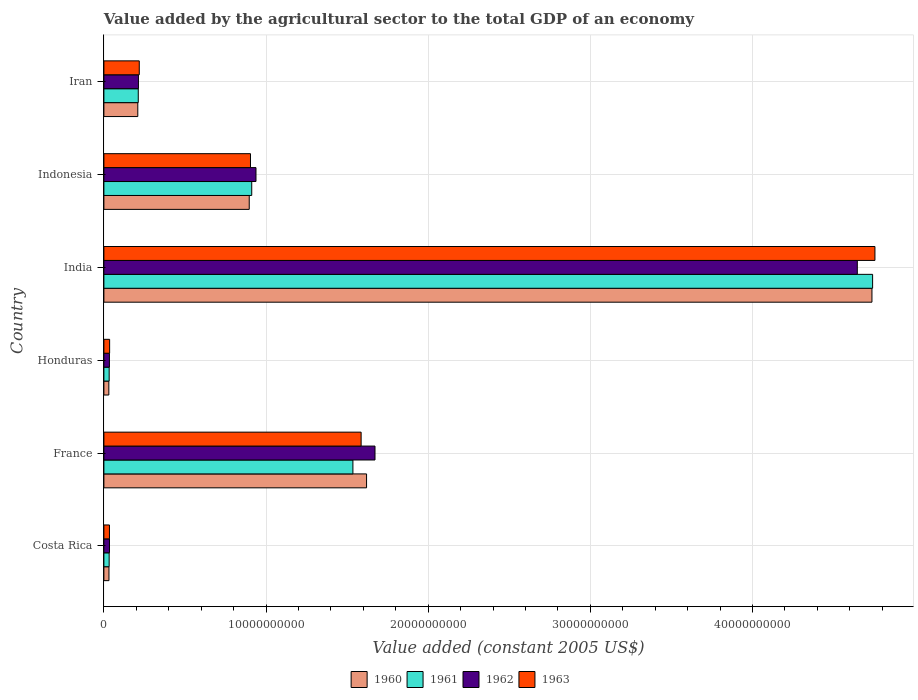How many groups of bars are there?
Keep it short and to the point. 6. Are the number of bars per tick equal to the number of legend labels?
Provide a succinct answer. Yes. What is the label of the 4th group of bars from the top?
Provide a short and direct response. Honduras. What is the value added by the agricultural sector in 1963 in Iran?
Offer a very short reply. 2.18e+09. Across all countries, what is the maximum value added by the agricultural sector in 1960?
Make the answer very short. 4.74e+1. Across all countries, what is the minimum value added by the agricultural sector in 1963?
Provide a succinct answer. 3.43e+08. What is the total value added by the agricultural sector in 1962 in the graph?
Offer a terse response. 7.54e+1. What is the difference between the value added by the agricultural sector in 1963 in Indonesia and that in Iran?
Provide a short and direct response. 6.86e+09. What is the difference between the value added by the agricultural sector in 1960 in Costa Rica and the value added by the agricultural sector in 1963 in Iran?
Make the answer very short. -1.87e+09. What is the average value added by the agricultural sector in 1961 per country?
Provide a short and direct response. 1.24e+1. What is the difference between the value added by the agricultural sector in 1963 and value added by the agricultural sector in 1961 in Costa Rica?
Your response must be concise. 1.89e+07. In how many countries, is the value added by the agricultural sector in 1963 greater than 16000000000 US$?
Make the answer very short. 1. What is the ratio of the value added by the agricultural sector in 1960 in France to that in Honduras?
Provide a succinct answer. 53.05. Is the value added by the agricultural sector in 1961 in France less than that in Indonesia?
Offer a very short reply. No. Is the difference between the value added by the agricultural sector in 1963 in Honduras and Iran greater than the difference between the value added by the agricultural sector in 1961 in Honduras and Iran?
Your answer should be very brief. No. What is the difference between the highest and the second highest value added by the agricultural sector in 1963?
Give a very brief answer. 3.17e+1. What is the difference between the highest and the lowest value added by the agricultural sector in 1963?
Make the answer very short. 4.72e+1. In how many countries, is the value added by the agricultural sector in 1962 greater than the average value added by the agricultural sector in 1962 taken over all countries?
Your answer should be compact. 2. Is it the case that in every country, the sum of the value added by the agricultural sector in 1961 and value added by the agricultural sector in 1960 is greater than the sum of value added by the agricultural sector in 1963 and value added by the agricultural sector in 1962?
Your answer should be very brief. No. Are the values on the major ticks of X-axis written in scientific E-notation?
Make the answer very short. No. Does the graph contain any zero values?
Your response must be concise. No. Does the graph contain grids?
Ensure brevity in your answer.  Yes. What is the title of the graph?
Keep it short and to the point. Value added by the agricultural sector to the total GDP of an economy. What is the label or title of the X-axis?
Offer a terse response. Value added (constant 2005 US$). What is the Value added (constant 2005 US$) of 1960 in Costa Rica?
Keep it short and to the point. 3.13e+08. What is the Value added (constant 2005 US$) of 1961 in Costa Rica?
Offer a very short reply. 3.24e+08. What is the Value added (constant 2005 US$) of 1962 in Costa Rica?
Offer a terse response. 3.44e+08. What is the Value added (constant 2005 US$) of 1963 in Costa Rica?
Provide a succinct answer. 3.43e+08. What is the Value added (constant 2005 US$) in 1960 in France?
Ensure brevity in your answer.  1.62e+1. What is the Value added (constant 2005 US$) in 1961 in France?
Offer a very short reply. 1.54e+1. What is the Value added (constant 2005 US$) of 1962 in France?
Your answer should be compact. 1.67e+1. What is the Value added (constant 2005 US$) in 1963 in France?
Provide a short and direct response. 1.59e+1. What is the Value added (constant 2005 US$) in 1960 in Honduras?
Your answer should be very brief. 3.05e+08. What is the Value added (constant 2005 US$) of 1961 in Honduras?
Your answer should be very brief. 3.25e+08. What is the Value added (constant 2005 US$) of 1962 in Honduras?
Offer a terse response. 3.41e+08. What is the Value added (constant 2005 US$) of 1963 in Honduras?
Provide a short and direct response. 3.53e+08. What is the Value added (constant 2005 US$) in 1960 in India?
Keep it short and to the point. 4.74e+1. What is the Value added (constant 2005 US$) in 1961 in India?
Offer a very short reply. 4.74e+1. What is the Value added (constant 2005 US$) of 1962 in India?
Keep it short and to the point. 4.65e+1. What is the Value added (constant 2005 US$) of 1963 in India?
Your response must be concise. 4.76e+1. What is the Value added (constant 2005 US$) of 1960 in Indonesia?
Your response must be concise. 8.96e+09. What is the Value added (constant 2005 US$) of 1961 in Indonesia?
Provide a short and direct response. 9.12e+09. What is the Value added (constant 2005 US$) in 1962 in Indonesia?
Give a very brief answer. 9.38e+09. What is the Value added (constant 2005 US$) of 1963 in Indonesia?
Make the answer very short. 9.04e+09. What is the Value added (constant 2005 US$) of 1960 in Iran?
Keep it short and to the point. 2.09e+09. What is the Value added (constant 2005 US$) of 1961 in Iran?
Provide a short and direct response. 2.12e+09. What is the Value added (constant 2005 US$) in 1962 in Iran?
Provide a short and direct response. 2.13e+09. What is the Value added (constant 2005 US$) in 1963 in Iran?
Offer a terse response. 2.18e+09. Across all countries, what is the maximum Value added (constant 2005 US$) in 1960?
Ensure brevity in your answer.  4.74e+1. Across all countries, what is the maximum Value added (constant 2005 US$) of 1961?
Ensure brevity in your answer.  4.74e+1. Across all countries, what is the maximum Value added (constant 2005 US$) of 1962?
Keep it short and to the point. 4.65e+1. Across all countries, what is the maximum Value added (constant 2005 US$) of 1963?
Offer a very short reply. 4.76e+1. Across all countries, what is the minimum Value added (constant 2005 US$) of 1960?
Ensure brevity in your answer.  3.05e+08. Across all countries, what is the minimum Value added (constant 2005 US$) of 1961?
Your response must be concise. 3.24e+08. Across all countries, what is the minimum Value added (constant 2005 US$) of 1962?
Provide a succinct answer. 3.41e+08. Across all countries, what is the minimum Value added (constant 2005 US$) in 1963?
Ensure brevity in your answer.  3.43e+08. What is the total Value added (constant 2005 US$) in 1960 in the graph?
Keep it short and to the point. 7.52e+1. What is the total Value added (constant 2005 US$) in 1961 in the graph?
Offer a very short reply. 7.47e+1. What is the total Value added (constant 2005 US$) of 1962 in the graph?
Give a very brief answer. 7.54e+1. What is the total Value added (constant 2005 US$) of 1963 in the graph?
Ensure brevity in your answer.  7.53e+1. What is the difference between the Value added (constant 2005 US$) of 1960 in Costa Rica and that in France?
Offer a terse response. -1.59e+1. What is the difference between the Value added (constant 2005 US$) of 1961 in Costa Rica and that in France?
Offer a very short reply. -1.50e+1. What is the difference between the Value added (constant 2005 US$) of 1962 in Costa Rica and that in France?
Your answer should be very brief. -1.64e+1. What is the difference between the Value added (constant 2005 US$) of 1963 in Costa Rica and that in France?
Provide a short and direct response. -1.55e+1. What is the difference between the Value added (constant 2005 US$) of 1960 in Costa Rica and that in Honduras?
Provide a succinct answer. 7.61e+06. What is the difference between the Value added (constant 2005 US$) of 1961 in Costa Rica and that in Honduras?
Offer a very short reply. -8.14e+05. What is the difference between the Value added (constant 2005 US$) in 1962 in Costa Rica and that in Honduras?
Offer a very short reply. 3.61e+06. What is the difference between the Value added (constant 2005 US$) of 1963 in Costa Rica and that in Honduras?
Your response must be concise. -9.78e+06. What is the difference between the Value added (constant 2005 US$) of 1960 in Costa Rica and that in India?
Give a very brief answer. -4.71e+1. What is the difference between the Value added (constant 2005 US$) in 1961 in Costa Rica and that in India?
Offer a very short reply. -4.71e+1. What is the difference between the Value added (constant 2005 US$) in 1962 in Costa Rica and that in India?
Ensure brevity in your answer.  -4.61e+1. What is the difference between the Value added (constant 2005 US$) of 1963 in Costa Rica and that in India?
Your answer should be compact. -4.72e+1. What is the difference between the Value added (constant 2005 US$) of 1960 in Costa Rica and that in Indonesia?
Your response must be concise. -8.65e+09. What is the difference between the Value added (constant 2005 US$) in 1961 in Costa Rica and that in Indonesia?
Ensure brevity in your answer.  -8.79e+09. What is the difference between the Value added (constant 2005 US$) of 1962 in Costa Rica and that in Indonesia?
Your answer should be compact. -9.03e+09. What is the difference between the Value added (constant 2005 US$) in 1963 in Costa Rica and that in Indonesia?
Ensure brevity in your answer.  -8.70e+09. What is the difference between the Value added (constant 2005 US$) in 1960 in Costa Rica and that in Iran?
Offer a terse response. -1.78e+09. What is the difference between the Value added (constant 2005 US$) of 1961 in Costa Rica and that in Iran?
Offer a very short reply. -1.80e+09. What is the difference between the Value added (constant 2005 US$) in 1962 in Costa Rica and that in Iran?
Provide a succinct answer. -1.79e+09. What is the difference between the Value added (constant 2005 US$) of 1963 in Costa Rica and that in Iran?
Ensure brevity in your answer.  -1.84e+09. What is the difference between the Value added (constant 2005 US$) in 1960 in France and that in Honduras?
Offer a very short reply. 1.59e+1. What is the difference between the Value added (constant 2005 US$) of 1961 in France and that in Honduras?
Your response must be concise. 1.50e+1. What is the difference between the Value added (constant 2005 US$) in 1962 in France and that in Honduras?
Ensure brevity in your answer.  1.64e+1. What is the difference between the Value added (constant 2005 US$) of 1963 in France and that in Honduras?
Your response must be concise. 1.55e+1. What is the difference between the Value added (constant 2005 US$) of 1960 in France and that in India?
Make the answer very short. -3.12e+1. What is the difference between the Value added (constant 2005 US$) in 1961 in France and that in India?
Your answer should be compact. -3.21e+1. What is the difference between the Value added (constant 2005 US$) in 1962 in France and that in India?
Ensure brevity in your answer.  -2.97e+1. What is the difference between the Value added (constant 2005 US$) of 1963 in France and that in India?
Ensure brevity in your answer.  -3.17e+1. What is the difference between the Value added (constant 2005 US$) of 1960 in France and that in Indonesia?
Keep it short and to the point. 7.24e+09. What is the difference between the Value added (constant 2005 US$) of 1961 in France and that in Indonesia?
Your answer should be compact. 6.24e+09. What is the difference between the Value added (constant 2005 US$) of 1962 in France and that in Indonesia?
Make the answer very short. 7.34e+09. What is the difference between the Value added (constant 2005 US$) in 1963 in France and that in Indonesia?
Give a very brief answer. 6.82e+09. What is the difference between the Value added (constant 2005 US$) of 1960 in France and that in Iran?
Provide a succinct answer. 1.41e+1. What is the difference between the Value added (constant 2005 US$) of 1961 in France and that in Iran?
Ensure brevity in your answer.  1.32e+1. What is the difference between the Value added (constant 2005 US$) in 1962 in France and that in Iran?
Make the answer very short. 1.46e+1. What is the difference between the Value added (constant 2005 US$) of 1963 in France and that in Iran?
Keep it short and to the point. 1.37e+1. What is the difference between the Value added (constant 2005 US$) of 1960 in Honduras and that in India?
Provide a succinct answer. -4.71e+1. What is the difference between the Value added (constant 2005 US$) in 1961 in Honduras and that in India?
Your answer should be very brief. -4.71e+1. What is the difference between the Value added (constant 2005 US$) in 1962 in Honduras and that in India?
Your answer should be very brief. -4.61e+1. What is the difference between the Value added (constant 2005 US$) of 1963 in Honduras and that in India?
Ensure brevity in your answer.  -4.72e+1. What is the difference between the Value added (constant 2005 US$) in 1960 in Honduras and that in Indonesia?
Give a very brief answer. -8.66e+09. What is the difference between the Value added (constant 2005 US$) of 1961 in Honduras and that in Indonesia?
Your answer should be very brief. -8.79e+09. What is the difference between the Value added (constant 2005 US$) in 1962 in Honduras and that in Indonesia?
Give a very brief answer. -9.04e+09. What is the difference between the Value added (constant 2005 US$) in 1963 in Honduras and that in Indonesia?
Give a very brief answer. -8.69e+09. What is the difference between the Value added (constant 2005 US$) in 1960 in Honduras and that in Iran?
Your answer should be very brief. -1.79e+09. What is the difference between the Value added (constant 2005 US$) of 1961 in Honduras and that in Iran?
Your answer should be compact. -1.79e+09. What is the difference between the Value added (constant 2005 US$) in 1962 in Honduras and that in Iran?
Provide a short and direct response. -1.79e+09. What is the difference between the Value added (constant 2005 US$) of 1963 in Honduras and that in Iran?
Your answer should be compact. -1.83e+09. What is the difference between the Value added (constant 2005 US$) in 1960 in India and that in Indonesia?
Ensure brevity in your answer.  3.84e+1. What is the difference between the Value added (constant 2005 US$) of 1961 in India and that in Indonesia?
Provide a short and direct response. 3.83e+1. What is the difference between the Value added (constant 2005 US$) of 1962 in India and that in Indonesia?
Ensure brevity in your answer.  3.71e+1. What is the difference between the Value added (constant 2005 US$) of 1963 in India and that in Indonesia?
Your answer should be compact. 3.85e+1. What is the difference between the Value added (constant 2005 US$) in 1960 in India and that in Iran?
Provide a succinct answer. 4.53e+1. What is the difference between the Value added (constant 2005 US$) of 1961 in India and that in Iran?
Your answer should be compact. 4.53e+1. What is the difference between the Value added (constant 2005 US$) in 1962 in India and that in Iran?
Offer a terse response. 4.43e+1. What is the difference between the Value added (constant 2005 US$) in 1963 in India and that in Iran?
Your answer should be very brief. 4.54e+1. What is the difference between the Value added (constant 2005 US$) in 1960 in Indonesia and that in Iran?
Keep it short and to the point. 6.87e+09. What is the difference between the Value added (constant 2005 US$) of 1961 in Indonesia and that in Iran?
Give a very brief answer. 7.00e+09. What is the difference between the Value added (constant 2005 US$) in 1962 in Indonesia and that in Iran?
Ensure brevity in your answer.  7.25e+09. What is the difference between the Value added (constant 2005 US$) in 1963 in Indonesia and that in Iran?
Give a very brief answer. 6.86e+09. What is the difference between the Value added (constant 2005 US$) of 1960 in Costa Rica and the Value added (constant 2005 US$) of 1961 in France?
Offer a very short reply. -1.50e+1. What is the difference between the Value added (constant 2005 US$) of 1960 in Costa Rica and the Value added (constant 2005 US$) of 1962 in France?
Offer a terse response. -1.64e+1. What is the difference between the Value added (constant 2005 US$) of 1960 in Costa Rica and the Value added (constant 2005 US$) of 1963 in France?
Provide a succinct answer. -1.56e+1. What is the difference between the Value added (constant 2005 US$) of 1961 in Costa Rica and the Value added (constant 2005 US$) of 1962 in France?
Your answer should be compact. -1.64e+1. What is the difference between the Value added (constant 2005 US$) of 1961 in Costa Rica and the Value added (constant 2005 US$) of 1963 in France?
Provide a short and direct response. -1.55e+1. What is the difference between the Value added (constant 2005 US$) in 1962 in Costa Rica and the Value added (constant 2005 US$) in 1963 in France?
Your answer should be very brief. -1.55e+1. What is the difference between the Value added (constant 2005 US$) of 1960 in Costa Rica and the Value added (constant 2005 US$) of 1961 in Honduras?
Offer a terse response. -1.23e+07. What is the difference between the Value added (constant 2005 US$) in 1960 in Costa Rica and the Value added (constant 2005 US$) in 1962 in Honduras?
Keep it short and to the point. -2.78e+07. What is the difference between the Value added (constant 2005 US$) in 1960 in Costa Rica and the Value added (constant 2005 US$) in 1963 in Honduras?
Give a very brief answer. -4.02e+07. What is the difference between the Value added (constant 2005 US$) of 1961 in Costa Rica and the Value added (constant 2005 US$) of 1962 in Honduras?
Your answer should be very brief. -1.63e+07. What is the difference between the Value added (constant 2005 US$) in 1961 in Costa Rica and the Value added (constant 2005 US$) in 1963 in Honduras?
Give a very brief answer. -2.87e+07. What is the difference between the Value added (constant 2005 US$) in 1962 in Costa Rica and the Value added (constant 2005 US$) in 1963 in Honduras?
Your answer should be very brief. -8.78e+06. What is the difference between the Value added (constant 2005 US$) of 1960 in Costa Rica and the Value added (constant 2005 US$) of 1961 in India?
Keep it short and to the point. -4.71e+1. What is the difference between the Value added (constant 2005 US$) of 1960 in Costa Rica and the Value added (constant 2005 US$) of 1962 in India?
Provide a succinct answer. -4.62e+1. What is the difference between the Value added (constant 2005 US$) of 1960 in Costa Rica and the Value added (constant 2005 US$) of 1963 in India?
Make the answer very short. -4.72e+1. What is the difference between the Value added (constant 2005 US$) of 1961 in Costa Rica and the Value added (constant 2005 US$) of 1962 in India?
Offer a very short reply. -4.61e+1. What is the difference between the Value added (constant 2005 US$) of 1961 in Costa Rica and the Value added (constant 2005 US$) of 1963 in India?
Ensure brevity in your answer.  -4.72e+1. What is the difference between the Value added (constant 2005 US$) of 1962 in Costa Rica and the Value added (constant 2005 US$) of 1963 in India?
Provide a succinct answer. -4.72e+1. What is the difference between the Value added (constant 2005 US$) in 1960 in Costa Rica and the Value added (constant 2005 US$) in 1961 in Indonesia?
Your response must be concise. -8.80e+09. What is the difference between the Value added (constant 2005 US$) of 1960 in Costa Rica and the Value added (constant 2005 US$) of 1962 in Indonesia?
Make the answer very short. -9.07e+09. What is the difference between the Value added (constant 2005 US$) of 1960 in Costa Rica and the Value added (constant 2005 US$) of 1963 in Indonesia?
Your response must be concise. -8.73e+09. What is the difference between the Value added (constant 2005 US$) of 1961 in Costa Rica and the Value added (constant 2005 US$) of 1962 in Indonesia?
Give a very brief answer. -9.05e+09. What is the difference between the Value added (constant 2005 US$) in 1961 in Costa Rica and the Value added (constant 2005 US$) in 1963 in Indonesia?
Offer a terse response. -8.72e+09. What is the difference between the Value added (constant 2005 US$) of 1962 in Costa Rica and the Value added (constant 2005 US$) of 1963 in Indonesia?
Provide a short and direct response. -8.70e+09. What is the difference between the Value added (constant 2005 US$) in 1960 in Costa Rica and the Value added (constant 2005 US$) in 1961 in Iran?
Make the answer very short. -1.81e+09. What is the difference between the Value added (constant 2005 US$) in 1960 in Costa Rica and the Value added (constant 2005 US$) in 1962 in Iran?
Offer a terse response. -1.82e+09. What is the difference between the Value added (constant 2005 US$) in 1960 in Costa Rica and the Value added (constant 2005 US$) in 1963 in Iran?
Make the answer very short. -1.87e+09. What is the difference between the Value added (constant 2005 US$) in 1961 in Costa Rica and the Value added (constant 2005 US$) in 1962 in Iran?
Provide a succinct answer. -1.81e+09. What is the difference between the Value added (constant 2005 US$) in 1961 in Costa Rica and the Value added (constant 2005 US$) in 1963 in Iran?
Your response must be concise. -1.86e+09. What is the difference between the Value added (constant 2005 US$) of 1962 in Costa Rica and the Value added (constant 2005 US$) of 1963 in Iran?
Offer a very short reply. -1.84e+09. What is the difference between the Value added (constant 2005 US$) in 1960 in France and the Value added (constant 2005 US$) in 1961 in Honduras?
Your response must be concise. 1.59e+1. What is the difference between the Value added (constant 2005 US$) in 1960 in France and the Value added (constant 2005 US$) in 1962 in Honduras?
Your answer should be compact. 1.59e+1. What is the difference between the Value added (constant 2005 US$) of 1960 in France and the Value added (constant 2005 US$) of 1963 in Honduras?
Provide a short and direct response. 1.58e+1. What is the difference between the Value added (constant 2005 US$) in 1961 in France and the Value added (constant 2005 US$) in 1962 in Honduras?
Provide a succinct answer. 1.50e+1. What is the difference between the Value added (constant 2005 US$) of 1961 in France and the Value added (constant 2005 US$) of 1963 in Honduras?
Your answer should be compact. 1.50e+1. What is the difference between the Value added (constant 2005 US$) of 1962 in France and the Value added (constant 2005 US$) of 1963 in Honduras?
Make the answer very short. 1.64e+1. What is the difference between the Value added (constant 2005 US$) of 1960 in France and the Value added (constant 2005 US$) of 1961 in India?
Offer a very short reply. -3.12e+1. What is the difference between the Value added (constant 2005 US$) in 1960 in France and the Value added (constant 2005 US$) in 1962 in India?
Your answer should be compact. -3.03e+1. What is the difference between the Value added (constant 2005 US$) in 1960 in France and the Value added (constant 2005 US$) in 1963 in India?
Offer a very short reply. -3.14e+1. What is the difference between the Value added (constant 2005 US$) of 1961 in France and the Value added (constant 2005 US$) of 1962 in India?
Provide a succinct answer. -3.11e+1. What is the difference between the Value added (constant 2005 US$) of 1961 in France and the Value added (constant 2005 US$) of 1963 in India?
Offer a terse response. -3.22e+1. What is the difference between the Value added (constant 2005 US$) in 1962 in France and the Value added (constant 2005 US$) in 1963 in India?
Your response must be concise. -3.08e+1. What is the difference between the Value added (constant 2005 US$) of 1960 in France and the Value added (constant 2005 US$) of 1961 in Indonesia?
Make the answer very short. 7.08e+09. What is the difference between the Value added (constant 2005 US$) in 1960 in France and the Value added (constant 2005 US$) in 1962 in Indonesia?
Give a very brief answer. 6.82e+09. What is the difference between the Value added (constant 2005 US$) in 1960 in France and the Value added (constant 2005 US$) in 1963 in Indonesia?
Keep it short and to the point. 7.16e+09. What is the difference between the Value added (constant 2005 US$) of 1961 in France and the Value added (constant 2005 US$) of 1962 in Indonesia?
Offer a terse response. 5.98e+09. What is the difference between the Value added (constant 2005 US$) of 1961 in France and the Value added (constant 2005 US$) of 1963 in Indonesia?
Provide a short and direct response. 6.32e+09. What is the difference between the Value added (constant 2005 US$) in 1962 in France and the Value added (constant 2005 US$) in 1963 in Indonesia?
Give a very brief answer. 7.68e+09. What is the difference between the Value added (constant 2005 US$) of 1960 in France and the Value added (constant 2005 US$) of 1961 in Iran?
Your answer should be compact. 1.41e+1. What is the difference between the Value added (constant 2005 US$) of 1960 in France and the Value added (constant 2005 US$) of 1962 in Iran?
Offer a terse response. 1.41e+1. What is the difference between the Value added (constant 2005 US$) in 1960 in France and the Value added (constant 2005 US$) in 1963 in Iran?
Provide a succinct answer. 1.40e+1. What is the difference between the Value added (constant 2005 US$) in 1961 in France and the Value added (constant 2005 US$) in 1962 in Iran?
Offer a terse response. 1.32e+1. What is the difference between the Value added (constant 2005 US$) in 1961 in France and the Value added (constant 2005 US$) in 1963 in Iran?
Offer a terse response. 1.32e+1. What is the difference between the Value added (constant 2005 US$) of 1962 in France and the Value added (constant 2005 US$) of 1963 in Iran?
Offer a terse response. 1.45e+1. What is the difference between the Value added (constant 2005 US$) of 1960 in Honduras and the Value added (constant 2005 US$) of 1961 in India?
Your answer should be compact. -4.71e+1. What is the difference between the Value added (constant 2005 US$) of 1960 in Honduras and the Value added (constant 2005 US$) of 1962 in India?
Your answer should be very brief. -4.62e+1. What is the difference between the Value added (constant 2005 US$) in 1960 in Honduras and the Value added (constant 2005 US$) in 1963 in India?
Your response must be concise. -4.72e+1. What is the difference between the Value added (constant 2005 US$) of 1961 in Honduras and the Value added (constant 2005 US$) of 1962 in India?
Your answer should be very brief. -4.61e+1. What is the difference between the Value added (constant 2005 US$) of 1961 in Honduras and the Value added (constant 2005 US$) of 1963 in India?
Your answer should be very brief. -4.72e+1. What is the difference between the Value added (constant 2005 US$) of 1962 in Honduras and the Value added (constant 2005 US$) of 1963 in India?
Keep it short and to the point. -4.72e+1. What is the difference between the Value added (constant 2005 US$) of 1960 in Honduras and the Value added (constant 2005 US$) of 1961 in Indonesia?
Your answer should be compact. -8.81e+09. What is the difference between the Value added (constant 2005 US$) in 1960 in Honduras and the Value added (constant 2005 US$) in 1962 in Indonesia?
Offer a terse response. -9.07e+09. What is the difference between the Value added (constant 2005 US$) in 1960 in Honduras and the Value added (constant 2005 US$) in 1963 in Indonesia?
Offer a terse response. -8.73e+09. What is the difference between the Value added (constant 2005 US$) in 1961 in Honduras and the Value added (constant 2005 US$) in 1962 in Indonesia?
Your answer should be compact. -9.05e+09. What is the difference between the Value added (constant 2005 US$) in 1961 in Honduras and the Value added (constant 2005 US$) in 1963 in Indonesia?
Keep it short and to the point. -8.72e+09. What is the difference between the Value added (constant 2005 US$) in 1962 in Honduras and the Value added (constant 2005 US$) in 1963 in Indonesia?
Make the answer very short. -8.70e+09. What is the difference between the Value added (constant 2005 US$) of 1960 in Honduras and the Value added (constant 2005 US$) of 1961 in Iran?
Ensure brevity in your answer.  -1.81e+09. What is the difference between the Value added (constant 2005 US$) of 1960 in Honduras and the Value added (constant 2005 US$) of 1962 in Iran?
Give a very brief answer. -1.82e+09. What is the difference between the Value added (constant 2005 US$) of 1960 in Honduras and the Value added (constant 2005 US$) of 1963 in Iran?
Offer a very short reply. -1.88e+09. What is the difference between the Value added (constant 2005 US$) of 1961 in Honduras and the Value added (constant 2005 US$) of 1962 in Iran?
Make the answer very short. -1.80e+09. What is the difference between the Value added (constant 2005 US$) in 1961 in Honduras and the Value added (constant 2005 US$) in 1963 in Iran?
Your answer should be compact. -1.86e+09. What is the difference between the Value added (constant 2005 US$) in 1962 in Honduras and the Value added (constant 2005 US$) in 1963 in Iran?
Offer a very short reply. -1.84e+09. What is the difference between the Value added (constant 2005 US$) of 1960 in India and the Value added (constant 2005 US$) of 1961 in Indonesia?
Make the answer very short. 3.83e+1. What is the difference between the Value added (constant 2005 US$) in 1960 in India and the Value added (constant 2005 US$) in 1962 in Indonesia?
Keep it short and to the point. 3.80e+1. What is the difference between the Value added (constant 2005 US$) in 1960 in India and the Value added (constant 2005 US$) in 1963 in Indonesia?
Make the answer very short. 3.83e+1. What is the difference between the Value added (constant 2005 US$) in 1961 in India and the Value added (constant 2005 US$) in 1962 in Indonesia?
Ensure brevity in your answer.  3.80e+1. What is the difference between the Value added (constant 2005 US$) in 1961 in India and the Value added (constant 2005 US$) in 1963 in Indonesia?
Offer a terse response. 3.84e+1. What is the difference between the Value added (constant 2005 US$) of 1962 in India and the Value added (constant 2005 US$) of 1963 in Indonesia?
Provide a succinct answer. 3.74e+1. What is the difference between the Value added (constant 2005 US$) in 1960 in India and the Value added (constant 2005 US$) in 1961 in Iran?
Make the answer very short. 4.52e+1. What is the difference between the Value added (constant 2005 US$) in 1960 in India and the Value added (constant 2005 US$) in 1962 in Iran?
Your response must be concise. 4.52e+1. What is the difference between the Value added (constant 2005 US$) in 1960 in India and the Value added (constant 2005 US$) in 1963 in Iran?
Your response must be concise. 4.52e+1. What is the difference between the Value added (constant 2005 US$) in 1961 in India and the Value added (constant 2005 US$) in 1962 in Iran?
Provide a short and direct response. 4.53e+1. What is the difference between the Value added (constant 2005 US$) in 1961 in India and the Value added (constant 2005 US$) in 1963 in Iran?
Keep it short and to the point. 4.52e+1. What is the difference between the Value added (constant 2005 US$) in 1962 in India and the Value added (constant 2005 US$) in 1963 in Iran?
Give a very brief answer. 4.43e+1. What is the difference between the Value added (constant 2005 US$) of 1960 in Indonesia and the Value added (constant 2005 US$) of 1961 in Iran?
Make the answer very short. 6.84e+09. What is the difference between the Value added (constant 2005 US$) of 1960 in Indonesia and the Value added (constant 2005 US$) of 1962 in Iran?
Ensure brevity in your answer.  6.83e+09. What is the difference between the Value added (constant 2005 US$) of 1960 in Indonesia and the Value added (constant 2005 US$) of 1963 in Iran?
Your response must be concise. 6.78e+09. What is the difference between the Value added (constant 2005 US$) in 1961 in Indonesia and the Value added (constant 2005 US$) in 1962 in Iran?
Offer a very short reply. 6.99e+09. What is the difference between the Value added (constant 2005 US$) in 1961 in Indonesia and the Value added (constant 2005 US$) in 1963 in Iran?
Make the answer very short. 6.94e+09. What is the difference between the Value added (constant 2005 US$) in 1962 in Indonesia and the Value added (constant 2005 US$) in 1963 in Iran?
Make the answer very short. 7.20e+09. What is the average Value added (constant 2005 US$) in 1960 per country?
Make the answer very short. 1.25e+1. What is the average Value added (constant 2005 US$) in 1961 per country?
Offer a terse response. 1.24e+1. What is the average Value added (constant 2005 US$) in 1962 per country?
Your response must be concise. 1.26e+1. What is the average Value added (constant 2005 US$) in 1963 per country?
Ensure brevity in your answer.  1.26e+1. What is the difference between the Value added (constant 2005 US$) of 1960 and Value added (constant 2005 US$) of 1961 in Costa Rica?
Provide a short and direct response. -1.15e+07. What is the difference between the Value added (constant 2005 US$) of 1960 and Value added (constant 2005 US$) of 1962 in Costa Rica?
Ensure brevity in your answer.  -3.14e+07. What is the difference between the Value added (constant 2005 US$) of 1960 and Value added (constant 2005 US$) of 1963 in Costa Rica?
Keep it short and to the point. -3.04e+07. What is the difference between the Value added (constant 2005 US$) in 1961 and Value added (constant 2005 US$) in 1962 in Costa Rica?
Offer a very short reply. -1.99e+07. What is the difference between the Value added (constant 2005 US$) of 1961 and Value added (constant 2005 US$) of 1963 in Costa Rica?
Your answer should be very brief. -1.89e+07. What is the difference between the Value added (constant 2005 US$) of 1962 and Value added (constant 2005 US$) of 1963 in Costa Rica?
Offer a terse response. 1.00e+06. What is the difference between the Value added (constant 2005 US$) of 1960 and Value added (constant 2005 US$) of 1961 in France?
Make the answer very short. 8.42e+08. What is the difference between the Value added (constant 2005 US$) in 1960 and Value added (constant 2005 US$) in 1962 in France?
Your answer should be compact. -5.20e+08. What is the difference between the Value added (constant 2005 US$) in 1960 and Value added (constant 2005 US$) in 1963 in France?
Keep it short and to the point. 3.35e+08. What is the difference between the Value added (constant 2005 US$) of 1961 and Value added (constant 2005 US$) of 1962 in France?
Offer a very short reply. -1.36e+09. What is the difference between the Value added (constant 2005 US$) in 1961 and Value added (constant 2005 US$) in 1963 in France?
Provide a succinct answer. -5.07e+08. What is the difference between the Value added (constant 2005 US$) in 1962 and Value added (constant 2005 US$) in 1963 in France?
Your answer should be very brief. 8.56e+08. What is the difference between the Value added (constant 2005 US$) of 1960 and Value added (constant 2005 US$) of 1961 in Honduras?
Your answer should be very brief. -1.99e+07. What is the difference between the Value added (constant 2005 US$) in 1960 and Value added (constant 2005 US$) in 1962 in Honduras?
Offer a very short reply. -3.54e+07. What is the difference between the Value added (constant 2005 US$) in 1960 and Value added (constant 2005 US$) in 1963 in Honduras?
Provide a succinct answer. -4.78e+07. What is the difference between the Value added (constant 2005 US$) in 1961 and Value added (constant 2005 US$) in 1962 in Honduras?
Keep it short and to the point. -1.55e+07. What is the difference between the Value added (constant 2005 US$) of 1961 and Value added (constant 2005 US$) of 1963 in Honduras?
Your answer should be very brief. -2.79e+07. What is the difference between the Value added (constant 2005 US$) in 1962 and Value added (constant 2005 US$) in 1963 in Honduras?
Offer a very short reply. -1.24e+07. What is the difference between the Value added (constant 2005 US$) of 1960 and Value added (constant 2005 US$) of 1961 in India?
Provide a short and direct response. -3.99e+07. What is the difference between the Value added (constant 2005 US$) in 1960 and Value added (constant 2005 US$) in 1962 in India?
Keep it short and to the point. 9.03e+08. What is the difference between the Value added (constant 2005 US$) in 1960 and Value added (constant 2005 US$) in 1963 in India?
Your answer should be very brief. -1.84e+08. What is the difference between the Value added (constant 2005 US$) of 1961 and Value added (constant 2005 US$) of 1962 in India?
Provide a short and direct response. 9.43e+08. What is the difference between the Value added (constant 2005 US$) of 1961 and Value added (constant 2005 US$) of 1963 in India?
Provide a short and direct response. -1.44e+08. What is the difference between the Value added (constant 2005 US$) of 1962 and Value added (constant 2005 US$) of 1963 in India?
Provide a succinct answer. -1.09e+09. What is the difference between the Value added (constant 2005 US$) in 1960 and Value added (constant 2005 US$) in 1961 in Indonesia?
Your answer should be compact. -1.54e+08. What is the difference between the Value added (constant 2005 US$) in 1960 and Value added (constant 2005 US$) in 1962 in Indonesia?
Your answer should be very brief. -4.16e+08. What is the difference between the Value added (constant 2005 US$) of 1960 and Value added (constant 2005 US$) of 1963 in Indonesia?
Your response must be concise. -7.71e+07. What is the difference between the Value added (constant 2005 US$) in 1961 and Value added (constant 2005 US$) in 1962 in Indonesia?
Offer a very short reply. -2.62e+08. What is the difference between the Value added (constant 2005 US$) in 1961 and Value added (constant 2005 US$) in 1963 in Indonesia?
Provide a succinct answer. 7.71e+07. What is the difference between the Value added (constant 2005 US$) of 1962 and Value added (constant 2005 US$) of 1963 in Indonesia?
Provide a succinct answer. 3.39e+08. What is the difference between the Value added (constant 2005 US$) in 1960 and Value added (constant 2005 US$) in 1961 in Iran?
Provide a succinct answer. -2.84e+07. What is the difference between the Value added (constant 2005 US$) in 1960 and Value added (constant 2005 US$) in 1962 in Iran?
Provide a succinct answer. -3.89e+07. What is the difference between the Value added (constant 2005 US$) in 1960 and Value added (constant 2005 US$) in 1963 in Iran?
Offer a very short reply. -9.02e+07. What is the difference between the Value added (constant 2005 US$) of 1961 and Value added (constant 2005 US$) of 1962 in Iran?
Keep it short and to the point. -1.05e+07. What is the difference between the Value added (constant 2005 US$) in 1961 and Value added (constant 2005 US$) in 1963 in Iran?
Offer a terse response. -6.18e+07. What is the difference between the Value added (constant 2005 US$) in 1962 and Value added (constant 2005 US$) in 1963 in Iran?
Offer a terse response. -5.13e+07. What is the ratio of the Value added (constant 2005 US$) of 1960 in Costa Rica to that in France?
Your answer should be very brief. 0.02. What is the ratio of the Value added (constant 2005 US$) in 1961 in Costa Rica to that in France?
Your answer should be very brief. 0.02. What is the ratio of the Value added (constant 2005 US$) of 1962 in Costa Rica to that in France?
Provide a succinct answer. 0.02. What is the ratio of the Value added (constant 2005 US$) in 1963 in Costa Rica to that in France?
Keep it short and to the point. 0.02. What is the ratio of the Value added (constant 2005 US$) of 1960 in Costa Rica to that in Honduras?
Your response must be concise. 1.02. What is the ratio of the Value added (constant 2005 US$) of 1962 in Costa Rica to that in Honduras?
Make the answer very short. 1.01. What is the ratio of the Value added (constant 2005 US$) of 1963 in Costa Rica to that in Honduras?
Your response must be concise. 0.97. What is the ratio of the Value added (constant 2005 US$) in 1960 in Costa Rica to that in India?
Offer a terse response. 0.01. What is the ratio of the Value added (constant 2005 US$) of 1961 in Costa Rica to that in India?
Ensure brevity in your answer.  0.01. What is the ratio of the Value added (constant 2005 US$) in 1962 in Costa Rica to that in India?
Your answer should be compact. 0.01. What is the ratio of the Value added (constant 2005 US$) in 1963 in Costa Rica to that in India?
Your response must be concise. 0.01. What is the ratio of the Value added (constant 2005 US$) in 1960 in Costa Rica to that in Indonesia?
Ensure brevity in your answer.  0.03. What is the ratio of the Value added (constant 2005 US$) in 1961 in Costa Rica to that in Indonesia?
Give a very brief answer. 0.04. What is the ratio of the Value added (constant 2005 US$) in 1962 in Costa Rica to that in Indonesia?
Your answer should be compact. 0.04. What is the ratio of the Value added (constant 2005 US$) of 1963 in Costa Rica to that in Indonesia?
Offer a very short reply. 0.04. What is the ratio of the Value added (constant 2005 US$) in 1960 in Costa Rica to that in Iran?
Offer a terse response. 0.15. What is the ratio of the Value added (constant 2005 US$) of 1961 in Costa Rica to that in Iran?
Provide a succinct answer. 0.15. What is the ratio of the Value added (constant 2005 US$) of 1962 in Costa Rica to that in Iran?
Keep it short and to the point. 0.16. What is the ratio of the Value added (constant 2005 US$) in 1963 in Costa Rica to that in Iran?
Your answer should be very brief. 0.16. What is the ratio of the Value added (constant 2005 US$) of 1960 in France to that in Honduras?
Provide a succinct answer. 53.05. What is the ratio of the Value added (constant 2005 US$) in 1961 in France to that in Honduras?
Your answer should be very brief. 47.21. What is the ratio of the Value added (constant 2005 US$) of 1962 in France to that in Honduras?
Offer a very short reply. 49.07. What is the ratio of the Value added (constant 2005 US$) of 1963 in France to that in Honduras?
Provide a short and direct response. 44.92. What is the ratio of the Value added (constant 2005 US$) in 1960 in France to that in India?
Make the answer very short. 0.34. What is the ratio of the Value added (constant 2005 US$) in 1961 in France to that in India?
Give a very brief answer. 0.32. What is the ratio of the Value added (constant 2005 US$) in 1962 in France to that in India?
Provide a succinct answer. 0.36. What is the ratio of the Value added (constant 2005 US$) in 1963 in France to that in India?
Provide a short and direct response. 0.33. What is the ratio of the Value added (constant 2005 US$) of 1960 in France to that in Indonesia?
Your answer should be compact. 1.81. What is the ratio of the Value added (constant 2005 US$) of 1961 in France to that in Indonesia?
Provide a succinct answer. 1.68. What is the ratio of the Value added (constant 2005 US$) of 1962 in France to that in Indonesia?
Provide a short and direct response. 1.78. What is the ratio of the Value added (constant 2005 US$) in 1963 in France to that in Indonesia?
Offer a very short reply. 1.75. What is the ratio of the Value added (constant 2005 US$) of 1960 in France to that in Iran?
Your answer should be compact. 7.75. What is the ratio of the Value added (constant 2005 US$) of 1961 in France to that in Iran?
Offer a very short reply. 7.24. What is the ratio of the Value added (constant 2005 US$) of 1962 in France to that in Iran?
Provide a succinct answer. 7.85. What is the ratio of the Value added (constant 2005 US$) of 1963 in France to that in Iran?
Offer a very short reply. 7.27. What is the ratio of the Value added (constant 2005 US$) of 1960 in Honduras to that in India?
Offer a terse response. 0.01. What is the ratio of the Value added (constant 2005 US$) in 1961 in Honduras to that in India?
Your answer should be very brief. 0.01. What is the ratio of the Value added (constant 2005 US$) in 1962 in Honduras to that in India?
Offer a very short reply. 0.01. What is the ratio of the Value added (constant 2005 US$) in 1963 in Honduras to that in India?
Your response must be concise. 0.01. What is the ratio of the Value added (constant 2005 US$) in 1960 in Honduras to that in Indonesia?
Keep it short and to the point. 0.03. What is the ratio of the Value added (constant 2005 US$) in 1961 in Honduras to that in Indonesia?
Give a very brief answer. 0.04. What is the ratio of the Value added (constant 2005 US$) in 1962 in Honduras to that in Indonesia?
Your answer should be compact. 0.04. What is the ratio of the Value added (constant 2005 US$) of 1963 in Honduras to that in Indonesia?
Provide a short and direct response. 0.04. What is the ratio of the Value added (constant 2005 US$) in 1960 in Honduras to that in Iran?
Ensure brevity in your answer.  0.15. What is the ratio of the Value added (constant 2005 US$) of 1961 in Honduras to that in Iran?
Provide a short and direct response. 0.15. What is the ratio of the Value added (constant 2005 US$) of 1962 in Honduras to that in Iran?
Your response must be concise. 0.16. What is the ratio of the Value added (constant 2005 US$) in 1963 in Honduras to that in Iran?
Your response must be concise. 0.16. What is the ratio of the Value added (constant 2005 US$) of 1960 in India to that in Indonesia?
Make the answer very short. 5.28. What is the ratio of the Value added (constant 2005 US$) in 1961 in India to that in Indonesia?
Your answer should be compact. 5.2. What is the ratio of the Value added (constant 2005 US$) in 1962 in India to that in Indonesia?
Offer a very short reply. 4.95. What is the ratio of the Value added (constant 2005 US$) of 1963 in India to that in Indonesia?
Ensure brevity in your answer.  5.26. What is the ratio of the Value added (constant 2005 US$) in 1960 in India to that in Iran?
Offer a very short reply. 22.65. What is the ratio of the Value added (constant 2005 US$) in 1961 in India to that in Iran?
Your answer should be compact. 22.37. What is the ratio of the Value added (constant 2005 US$) in 1962 in India to that in Iran?
Offer a terse response. 21.81. What is the ratio of the Value added (constant 2005 US$) of 1963 in India to that in Iran?
Your response must be concise. 21.8. What is the ratio of the Value added (constant 2005 US$) of 1960 in Indonesia to that in Iran?
Make the answer very short. 4.29. What is the ratio of the Value added (constant 2005 US$) of 1961 in Indonesia to that in Iran?
Ensure brevity in your answer.  4.3. What is the ratio of the Value added (constant 2005 US$) in 1962 in Indonesia to that in Iran?
Provide a succinct answer. 4.4. What is the ratio of the Value added (constant 2005 US$) in 1963 in Indonesia to that in Iran?
Your answer should be compact. 4.14. What is the difference between the highest and the second highest Value added (constant 2005 US$) in 1960?
Keep it short and to the point. 3.12e+1. What is the difference between the highest and the second highest Value added (constant 2005 US$) of 1961?
Make the answer very short. 3.21e+1. What is the difference between the highest and the second highest Value added (constant 2005 US$) in 1962?
Provide a succinct answer. 2.97e+1. What is the difference between the highest and the second highest Value added (constant 2005 US$) in 1963?
Ensure brevity in your answer.  3.17e+1. What is the difference between the highest and the lowest Value added (constant 2005 US$) of 1960?
Provide a short and direct response. 4.71e+1. What is the difference between the highest and the lowest Value added (constant 2005 US$) in 1961?
Ensure brevity in your answer.  4.71e+1. What is the difference between the highest and the lowest Value added (constant 2005 US$) of 1962?
Provide a succinct answer. 4.61e+1. What is the difference between the highest and the lowest Value added (constant 2005 US$) in 1963?
Your answer should be compact. 4.72e+1. 